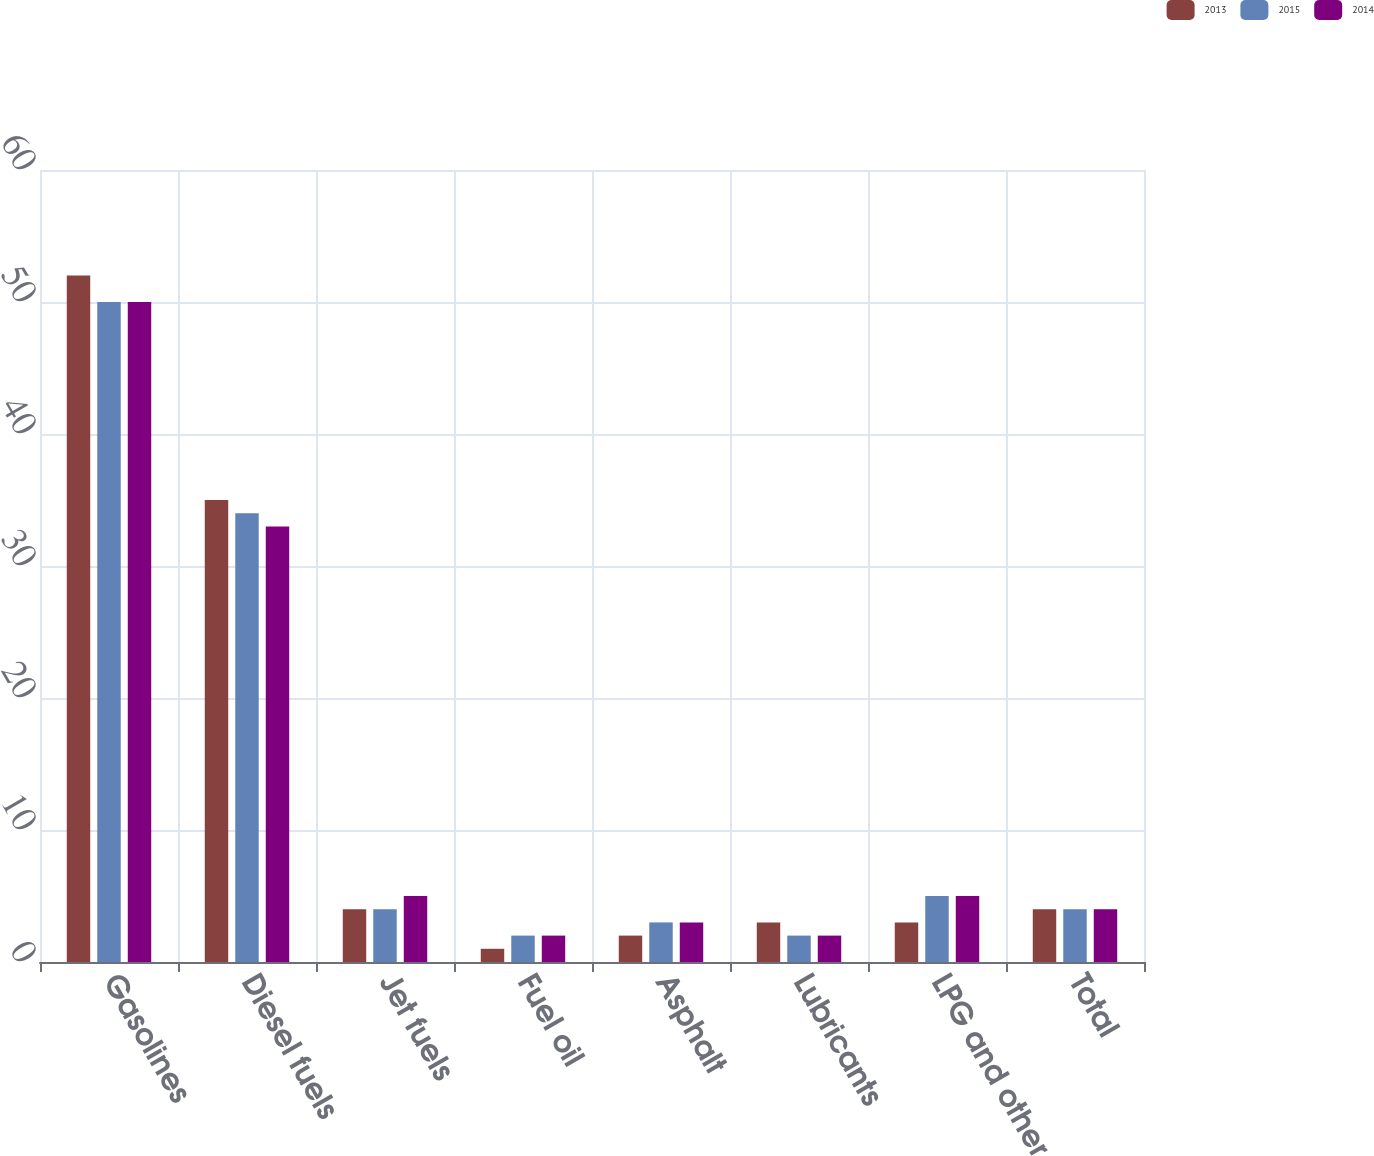Convert chart to OTSL. <chart><loc_0><loc_0><loc_500><loc_500><stacked_bar_chart><ecel><fcel>Gasolines<fcel>Diesel fuels<fcel>Jet fuels<fcel>Fuel oil<fcel>Asphalt<fcel>Lubricants<fcel>LPG and other<fcel>Total<nl><fcel>2013<fcel>52<fcel>35<fcel>4<fcel>1<fcel>2<fcel>3<fcel>3<fcel>4<nl><fcel>2015<fcel>50<fcel>34<fcel>4<fcel>2<fcel>3<fcel>2<fcel>5<fcel>4<nl><fcel>2014<fcel>50<fcel>33<fcel>5<fcel>2<fcel>3<fcel>2<fcel>5<fcel>4<nl></chart> 